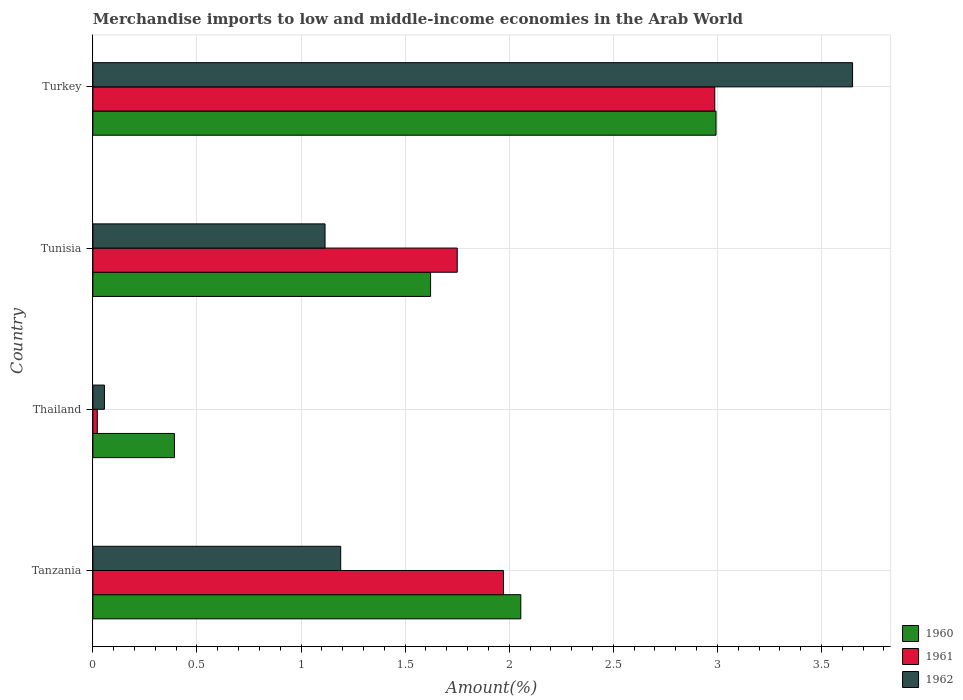How many different coloured bars are there?
Make the answer very short. 3. How many groups of bars are there?
Provide a succinct answer. 4. Are the number of bars per tick equal to the number of legend labels?
Give a very brief answer. Yes. How many bars are there on the 3rd tick from the top?
Provide a succinct answer. 3. How many bars are there on the 2nd tick from the bottom?
Make the answer very short. 3. What is the label of the 3rd group of bars from the top?
Offer a terse response. Thailand. In how many cases, is the number of bars for a given country not equal to the number of legend labels?
Your response must be concise. 0. What is the percentage of amount earned from merchandise imports in 1962 in Thailand?
Provide a short and direct response. 0.06. Across all countries, what is the maximum percentage of amount earned from merchandise imports in 1961?
Make the answer very short. 2.99. Across all countries, what is the minimum percentage of amount earned from merchandise imports in 1962?
Offer a terse response. 0.06. In which country was the percentage of amount earned from merchandise imports in 1961 maximum?
Provide a succinct answer. Turkey. In which country was the percentage of amount earned from merchandise imports in 1962 minimum?
Provide a short and direct response. Thailand. What is the total percentage of amount earned from merchandise imports in 1960 in the graph?
Ensure brevity in your answer.  7.06. What is the difference between the percentage of amount earned from merchandise imports in 1961 in Thailand and that in Tunisia?
Provide a short and direct response. -1.73. What is the difference between the percentage of amount earned from merchandise imports in 1961 in Turkey and the percentage of amount earned from merchandise imports in 1962 in Tanzania?
Provide a succinct answer. 1.8. What is the average percentage of amount earned from merchandise imports in 1961 per country?
Your response must be concise. 1.68. What is the difference between the percentage of amount earned from merchandise imports in 1962 and percentage of amount earned from merchandise imports in 1961 in Turkey?
Ensure brevity in your answer.  0.66. In how many countries, is the percentage of amount earned from merchandise imports in 1960 greater than 3.6 %?
Your answer should be compact. 0. What is the ratio of the percentage of amount earned from merchandise imports in 1960 in Thailand to that in Turkey?
Provide a short and direct response. 0.13. Is the percentage of amount earned from merchandise imports in 1960 in Tanzania less than that in Thailand?
Keep it short and to the point. No. Is the difference between the percentage of amount earned from merchandise imports in 1962 in Tunisia and Turkey greater than the difference between the percentage of amount earned from merchandise imports in 1961 in Tunisia and Turkey?
Your answer should be compact. No. What is the difference between the highest and the second highest percentage of amount earned from merchandise imports in 1961?
Your answer should be very brief. 1.02. What is the difference between the highest and the lowest percentage of amount earned from merchandise imports in 1960?
Offer a very short reply. 2.6. Is the sum of the percentage of amount earned from merchandise imports in 1961 in Thailand and Turkey greater than the maximum percentage of amount earned from merchandise imports in 1962 across all countries?
Keep it short and to the point. No. What does the 3rd bar from the top in Turkey represents?
Ensure brevity in your answer.  1960. What does the 1st bar from the bottom in Thailand represents?
Offer a terse response. 1960. Is it the case that in every country, the sum of the percentage of amount earned from merchandise imports in 1962 and percentage of amount earned from merchandise imports in 1961 is greater than the percentage of amount earned from merchandise imports in 1960?
Make the answer very short. No. How many bars are there?
Keep it short and to the point. 12. Are all the bars in the graph horizontal?
Offer a terse response. Yes. How many countries are there in the graph?
Your answer should be very brief. 4. What is the difference between two consecutive major ticks on the X-axis?
Your answer should be compact. 0.5. Does the graph contain any zero values?
Make the answer very short. No. Does the graph contain grids?
Make the answer very short. Yes. What is the title of the graph?
Ensure brevity in your answer.  Merchandise imports to low and middle-income economies in the Arab World. Does "1984" appear as one of the legend labels in the graph?
Your answer should be very brief. No. What is the label or title of the X-axis?
Your answer should be compact. Amount(%). What is the label or title of the Y-axis?
Offer a very short reply. Country. What is the Amount(%) in 1960 in Tanzania?
Keep it short and to the point. 2.06. What is the Amount(%) in 1961 in Tanzania?
Give a very brief answer. 1.97. What is the Amount(%) in 1962 in Tanzania?
Offer a very short reply. 1.19. What is the Amount(%) in 1960 in Thailand?
Ensure brevity in your answer.  0.39. What is the Amount(%) of 1961 in Thailand?
Keep it short and to the point. 0.02. What is the Amount(%) in 1962 in Thailand?
Ensure brevity in your answer.  0.06. What is the Amount(%) of 1960 in Tunisia?
Your answer should be compact. 1.62. What is the Amount(%) of 1961 in Tunisia?
Provide a succinct answer. 1.75. What is the Amount(%) of 1962 in Tunisia?
Your answer should be very brief. 1.12. What is the Amount(%) of 1960 in Turkey?
Provide a short and direct response. 2.99. What is the Amount(%) in 1961 in Turkey?
Provide a succinct answer. 2.99. What is the Amount(%) of 1962 in Turkey?
Offer a very short reply. 3.65. Across all countries, what is the maximum Amount(%) in 1960?
Keep it short and to the point. 2.99. Across all countries, what is the maximum Amount(%) in 1961?
Provide a succinct answer. 2.99. Across all countries, what is the maximum Amount(%) of 1962?
Your answer should be compact. 3.65. Across all countries, what is the minimum Amount(%) in 1960?
Offer a terse response. 0.39. Across all countries, what is the minimum Amount(%) in 1961?
Make the answer very short. 0.02. Across all countries, what is the minimum Amount(%) of 1962?
Make the answer very short. 0.06. What is the total Amount(%) of 1960 in the graph?
Provide a succinct answer. 7.06. What is the total Amount(%) of 1961 in the graph?
Give a very brief answer. 6.73. What is the total Amount(%) of 1962 in the graph?
Your answer should be compact. 6.01. What is the difference between the Amount(%) in 1960 in Tanzania and that in Thailand?
Offer a terse response. 1.66. What is the difference between the Amount(%) in 1961 in Tanzania and that in Thailand?
Ensure brevity in your answer.  1.95. What is the difference between the Amount(%) in 1962 in Tanzania and that in Thailand?
Offer a very short reply. 1.13. What is the difference between the Amount(%) in 1960 in Tanzania and that in Tunisia?
Ensure brevity in your answer.  0.43. What is the difference between the Amount(%) in 1961 in Tanzania and that in Tunisia?
Your answer should be very brief. 0.22. What is the difference between the Amount(%) of 1962 in Tanzania and that in Tunisia?
Give a very brief answer. 0.08. What is the difference between the Amount(%) in 1960 in Tanzania and that in Turkey?
Give a very brief answer. -0.94. What is the difference between the Amount(%) of 1961 in Tanzania and that in Turkey?
Your response must be concise. -1.02. What is the difference between the Amount(%) of 1962 in Tanzania and that in Turkey?
Your answer should be compact. -2.46. What is the difference between the Amount(%) of 1960 in Thailand and that in Tunisia?
Offer a terse response. -1.23. What is the difference between the Amount(%) of 1961 in Thailand and that in Tunisia?
Offer a very short reply. -1.73. What is the difference between the Amount(%) in 1962 in Thailand and that in Tunisia?
Give a very brief answer. -1.06. What is the difference between the Amount(%) of 1960 in Thailand and that in Turkey?
Your answer should be compact. -2.6. What is the difference between the Amount(%) of 1961 in Thailand and that in Turkey?
Offer a very short reply. -2.97. What is the difference between the Amount(%) in 1962 in Thailand and that in Turkey?
Your answer should be compact. -3.59. What is the difference between the Amount(%) in 1960 in Tunisia and that in Turkey?
Provide a short and direct response. -1.37. What is the difference between the Amount(%) of 1961 in Tunisia and that in Turkey?
Ensure brevity in your answer.  -1.24. What is the difference between the Amount(%) in 1962 in Tunisia and that in Turkey?
Your response must be concise. -2.53. What is the difference between the Amount(%) in 1960 in Tanzania and the Amount(%) in 1961 in Thailand?
Make the answer very short. 2.03. What is the difference between the Amount(%) of 1960 in Tanzania and the Amount(%) of 1962 in Thailand?
Provide a succinct answer. 2. What is the difference between the Amount(%) of 1961 in Tanzania and the Amount(%) of 1962 in Thailand?
Offer a terse response. 1.92. What is the difference between the Amount(%) of 1960 in Tanzania and the Amount(%) of 1961 in Tunisia?
Give a very brief answer. 0.31. What is the difference between the Amount(%) in 1960 in Tanzania and the Amount(%) in 1962 in Tunisia?
Offer a terse response. 0.94. What is the difference between the Amount(%) in 1961 in Tanzania and the Amount(%) in 1962 in Tunisia?
Offer a very short reply. 0.86. What is the difference between the Amount(%) of 1960 in Tanzania and the Amount(%) of 1961 in Turkey?
Your answer should be compact. -0.93. What is the difference between the Amount(%) in 1960 in Tanzania and the Amount(%) in 1962 in Turkey?
Give a very brief answer. -1.59. What is the difference between the Amount(%) in 1961 in Tanzania and the Amount(%) in 1962 in Turkey?
Make the answer very short. -1.68. What is the difference between the Amount(%) in 1960 in Thailand and the Amount(%) in 1961 in Tunisia?
Provide a short and direct response. -1.36. What is the difference between the Amount(%) in 1960 in Thailand and the Amount(%) in 1962 in Tunisia?
Keep it short and to the point. -0.72. What is the difference between the Amount(%) in 1961 in Thailand and the Amount(%) in 1962 in Tunisia?
Ensure brevity in your answer.  -1.09. What is the difference between the Amount(%) in 1960 in Thailand and the Amount(%) in 1961 in Turkey?
Provide a short and direct response. -2.6. What is the difference between the Amount(%) of 1960 in Thailand and the Amount(%) of 1962 in Turkey?
Your answer should be compact. -3.26. What is the difference between the Amount(%) of 1961 in Thailand and the Amount(%) of 1962 in Turkey?
Your response must be concise. -3.63. What is the difference between the Amount(%) in 1960 in Tunisia and the Amount(%) in 1961 in Turkey?
Offer a terse response. -1.37. What is the difference between the Amount(%) of 1960 in Tunisia and the Amount(%) of 1962 in Turkey?
Make the answer very short. -2.03. What is the difference between the Amount(%) in 1961 in Tunisia and the Amount(%) in 1962 in Turkey?
Give a very brief answer. -1.9. What is the average Amount(%) in 1960 per country?
Your answer should be compact. 1.77. What is the average Amount(%) in 1961 per country?
Your answer should be compact. 1.68. What is the average Amount(%) in 1962 per country?
Offer a very short reply. 1.5. What is the difference between the Amount(%) of 1960 and Amount(%) of 1961 in Tanzania?
Your answer should be very brief. 0.08. What is the difference between the Amount(%) of 1960 and Amount(%) of 1962 in Tanzania?
Offer a very short reply. 0.87. What is the difference between the Amount(%) in 1961 and Amount(%) in 1962 in Tanzania?
Offer a terse response. 0.78. What is the difference between the Amount(%) in 1960 and Amount(%) in 1961 in Thailand?
Keep it short and to the point. 0.37. What is the difference between the Amount(%) in 1960 and Amount(%) in 1962 in Thailand?
Offer a terse response. 0.34. What is the difference between the Amount(%) in 1961 and Amount(%) in 1962 in Thailand?
Ensure brevity in your answer.  -0.03. What is the difference between the Amount(%) in 1960 and Amount(%) in 1961 in Tunisia?
Your answer should be very brief. -0.13. What is the difference between the Amount(%) in 1960 and Amount(%) in 1962 in Tunisia?
Your answer should be very brief. 0.51. What is the difference between the Amount(%) of 1961 and Amount(%) of 1962 in Tunisia?
Offer a terse response. 0.64. What is the difference between the Amount(%) in 1960 and Amount(%) in 1961 in Turkey?
Ensure brevity in your answer.  0.01. What is the difference between the Amount(%) of 1960 and Amount(%) of 1962 in Turkey?
Make the answer very short. -0.66. What is the difference between the Amount(%) of 1961 and Amount(%) of 1962 in Turkey?
Provide a succinct answer. -0.66. What is the ratio of the Amount(%) of 1960 in Tanzania to that in Thailand?
Provide a succinct answer. 5.25. What is the ratio of the Amount(%) of 1961 in Tanzania to that in Thailand?
Give a very brief answer. 92.38. What is the ratio of the Amount(%) in 1962 in Tanzania to that in Thailand?
Offer a very short reply. 21.43. What is the ratio of the Amount(%) of 1960 in Tanzania to that in Tunisia?
Provide a succinct answer. 1.27. What is the ratio of the Amount(%) of 1961 in Tanzania to that in Tunisia?
Provide a short and direct response. 1.13. What is the ratio of the Amount(%) in 1962 in Tanzania to that in Tunisia?
Your response must be concise. 1.07. What is the ratio of the Amount(%) of 1960 in Tanzania to that in Turkey?
Make the answer very short. 0.69. What is the ratio of the Amount(%) of 1961 in Tanzania to that in Turkey?
Make the answer very short. 0.66. What is the ratio of the Amount(%) in 1962 in Tanzania to that in Turkey?
Offer a very short reply. 0.33. What is the ratio of the Amount(%) in 1960 in Thailand to that in Tunisia?
Keep it short and to the point. 0.24. What is the ratio of the Amount(%) in 1961 in Thailand to that in Tunisia?
Ensure brevity in your answer.  0.01. What is the ratio of the Amount(%) in 1962 in Thailand to that in Tunisia?
Your answer should be compact. 0.05. What is the ratio of the Amount(%) of 1960 in Thailand to that in Turkey?
Your answer should be very brief. 0.13. What is the ratio of the Amount(%) in 1961 in Thailand to that in Turkey?
Make the answer very short. 0.01. What is the ratio of the Amount(%) in 1962 in Thailand to that in Turkey?
Keep it short and to the point. 0.02. What is the ratio of the Amount(%) of 1960 in Tunisia to that in Turkey?
Provide a short and direct response. 0.54. What is the ratio of the Amount(%) of 1961 in Tunisia to that in Turkey?
Provide a short and direct response. 0.59. What is the ratio of the Amount(%) of 1962 in Tunisia to that in Turkey?
Offer a very short reply. 0.31. What is the difference between the highest and the second highest Amount(%) in 1960?
Provide a succinct answer. 0.94. What is the difference between the highest and the second highest Amount(%) in 1961?
Your response must be concise. 1.02. What is the difference between the highest and the second highest Amount(%) of 1962?
Offer a terse response. 2.46. What is the difference between the highest and the lowest Amount(%) of 1960?
Make the answer very short. 2.6. What is the difference between the highest and the lowest Amount(%) of 1961?
Make the answer very short. 2.97. What is the difference between the highest and the lowest Amount(%) in 1962?
Provide a succinct answer. 3.59. 